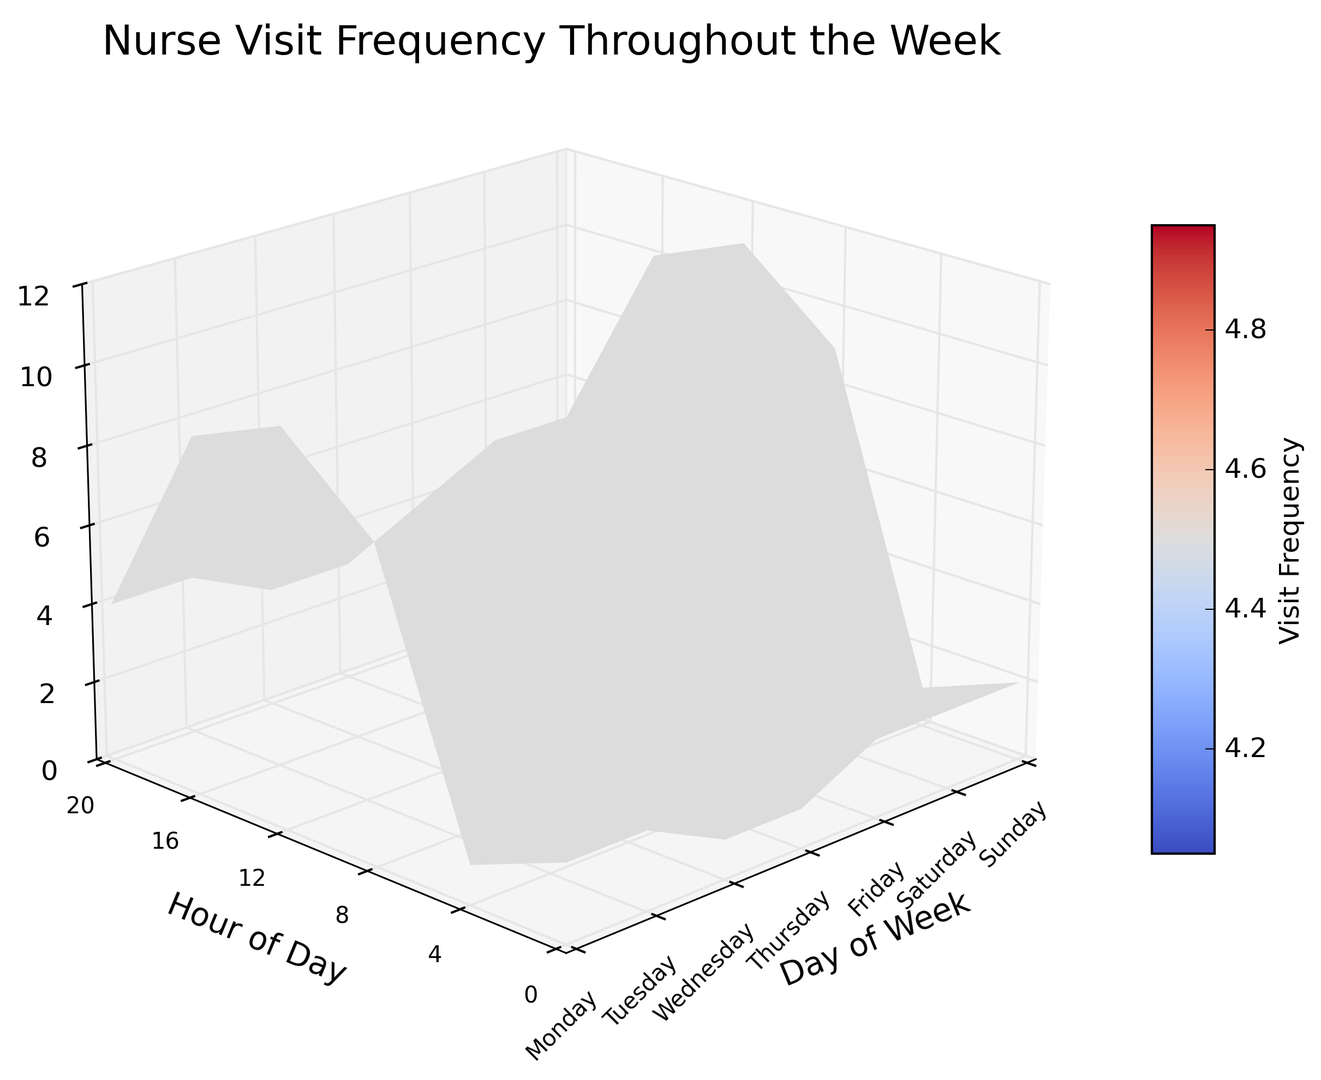What day has the highest nurse visit frequency at 12 PM? By observing the height of the peaks in the chart at 12 PM, we can determine which day has the tallest peak. On Tuesday and Wednesday at 12 PM, the peak reaches the highest point.
Answer: Tuesday and Wednesday Which day has the lowest visit frequency at 4 AM? Observe the valleys at 4 AM to see which day has the lowest part. All days have equally low values at 4 AM.
Answer: All days Does Monday have more visits at 8 AM or 8 PM? Look at the height of the peaks on Monday at both 8 AM and 8 PM. 8 AM is higher than 8 PM.
Answer: 8 AM What is the total number of visits at 8 AM throughout the week? Sum the frequency values at 8 AM for all days: 8 + 9 + 9 + 8 + 8 + 6 + 6 = 54.
Answer: 54 Compare the visit frequency between 0 AM on Monday and 0 AM on Thursday. Which one has more visits? By examining the heights at 0 AM for Monday and Thursday and comparing them, we see that both are of the same height.
Answer: Equal On which day is the variation in visit frequency throughout the day the smallest? Look for the day where the peaks and valleys are closest together. Saturday and Sunday have the smallest variation.
Answer: Saturday and Sunday How does the visit frequency on Friday at 12 PM compare to that on Sunday at 12 PM? Observe the heights at 12 PM on Friday and Sunday. Friday appears higher than Sunday.
Answer: Friday is higher At what time of day is visit frequency consistently at its minimum throughout the week? Look for the time with the lowest peaks across all days. 4 AM is consistently low.
Answer: 4 AM 